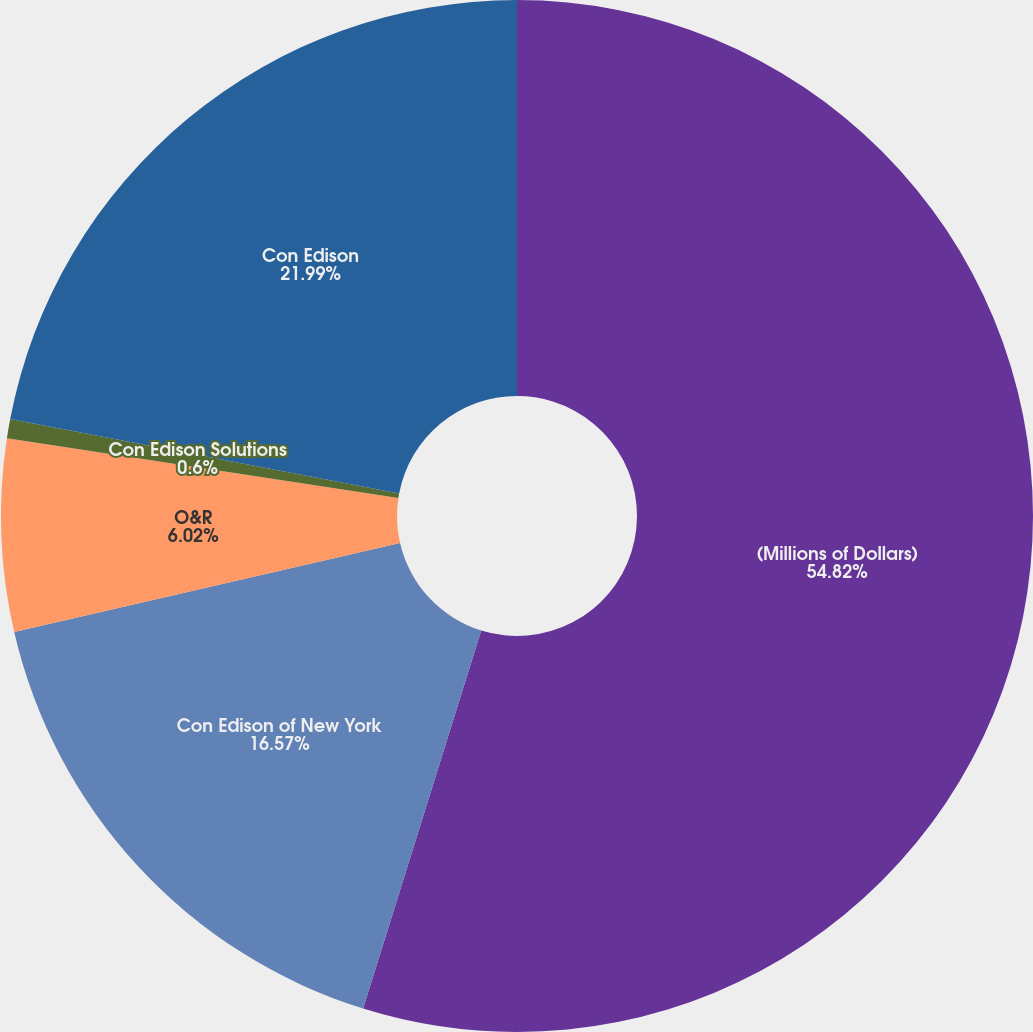<chart> <loc_0><loc_0><loc_500><loc_500><pie_chart><fcel>(Millions of Dollars)<fcel>Con Edison of New York<fcel>O&R<fcel>Con Edison Solutions<fcel>Con Edison<nl><fcel>54.82%<fcel>16.57%<fcel>6.02%<fcel>0.6%<fcel>21.99%<nl></chart> 